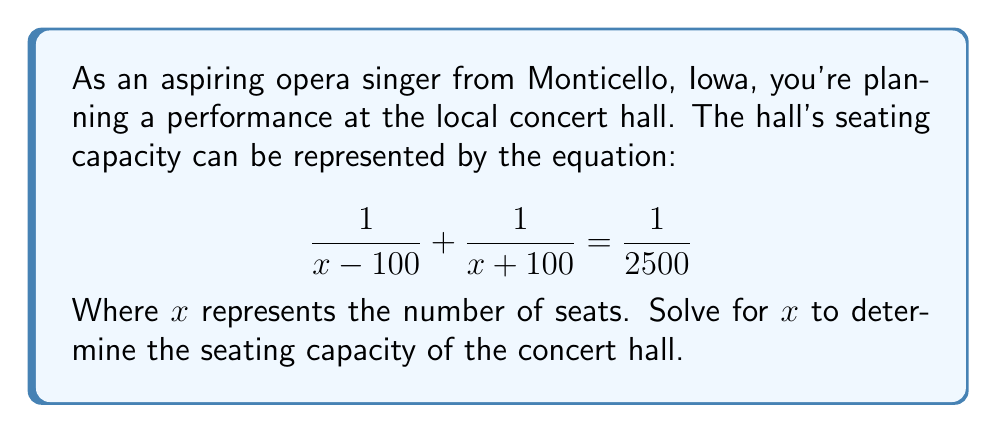Provide a solution to this math problem. Let's solve this step-by-step:

1) First, let's find a common denominator to add the fractions on the left side:
   $$\frac{x + 100}{(x - 100)(x + 100)} + \frac{x - 100}{(x - 100)(x + 100)} = \frac{1}{2500}$$

2) Add the numerators:
   $$\frac{(x + 100) + (x - 100)}{(x - 100)(x + 100)} = \frac{1}{2500}$$

3) Simplify the numerator:
   $$\frac{2x}{(x - 100)(x + 100)} = \frac{1}{2500}$$

4) Cross multiply:
   $$2500(2x) = (x - 100)(x + 100)$$

5) Distribute on the right side:
   $$5000x = x^2 - 10000$$

6) Rearrange to standard form:
   $$x^2 - 5000x - 10000 = 0$$

7) This is a quadratic equation. We can solve it using the quadratic formula:
   $$x = \frac{-b \pm \sqrt{b^2 - 4ac}}{2a}$$
   Where $a = 1$, $b = -5000$, and $c = -10000$

8) Plugging in these values:
   $$x = \frac{5000 \pm \sqrt{(-5000)^2 - 4(1)(-10000)}}{2(1)}$$

9) Simplify under the square root:
   $$x = \frac{5000 \pm \sqrt{25000000 + 40000}}{2} = \frac{5000 \pm \sqrt{25040000}}{2}$$

10) Simplify the square root:
    $$x = \frac{5000 \pm 5004}{2}$$

11) This gives us two solutions:
    $$x = \frac{5000 + 5004}{2} = 5002$$ or $$x = \frac{5000 - 5004}{2} = -2$$

12) Since we're dealing with seating capacity, we can discard the negative solution.
Answer: 5002 seats 